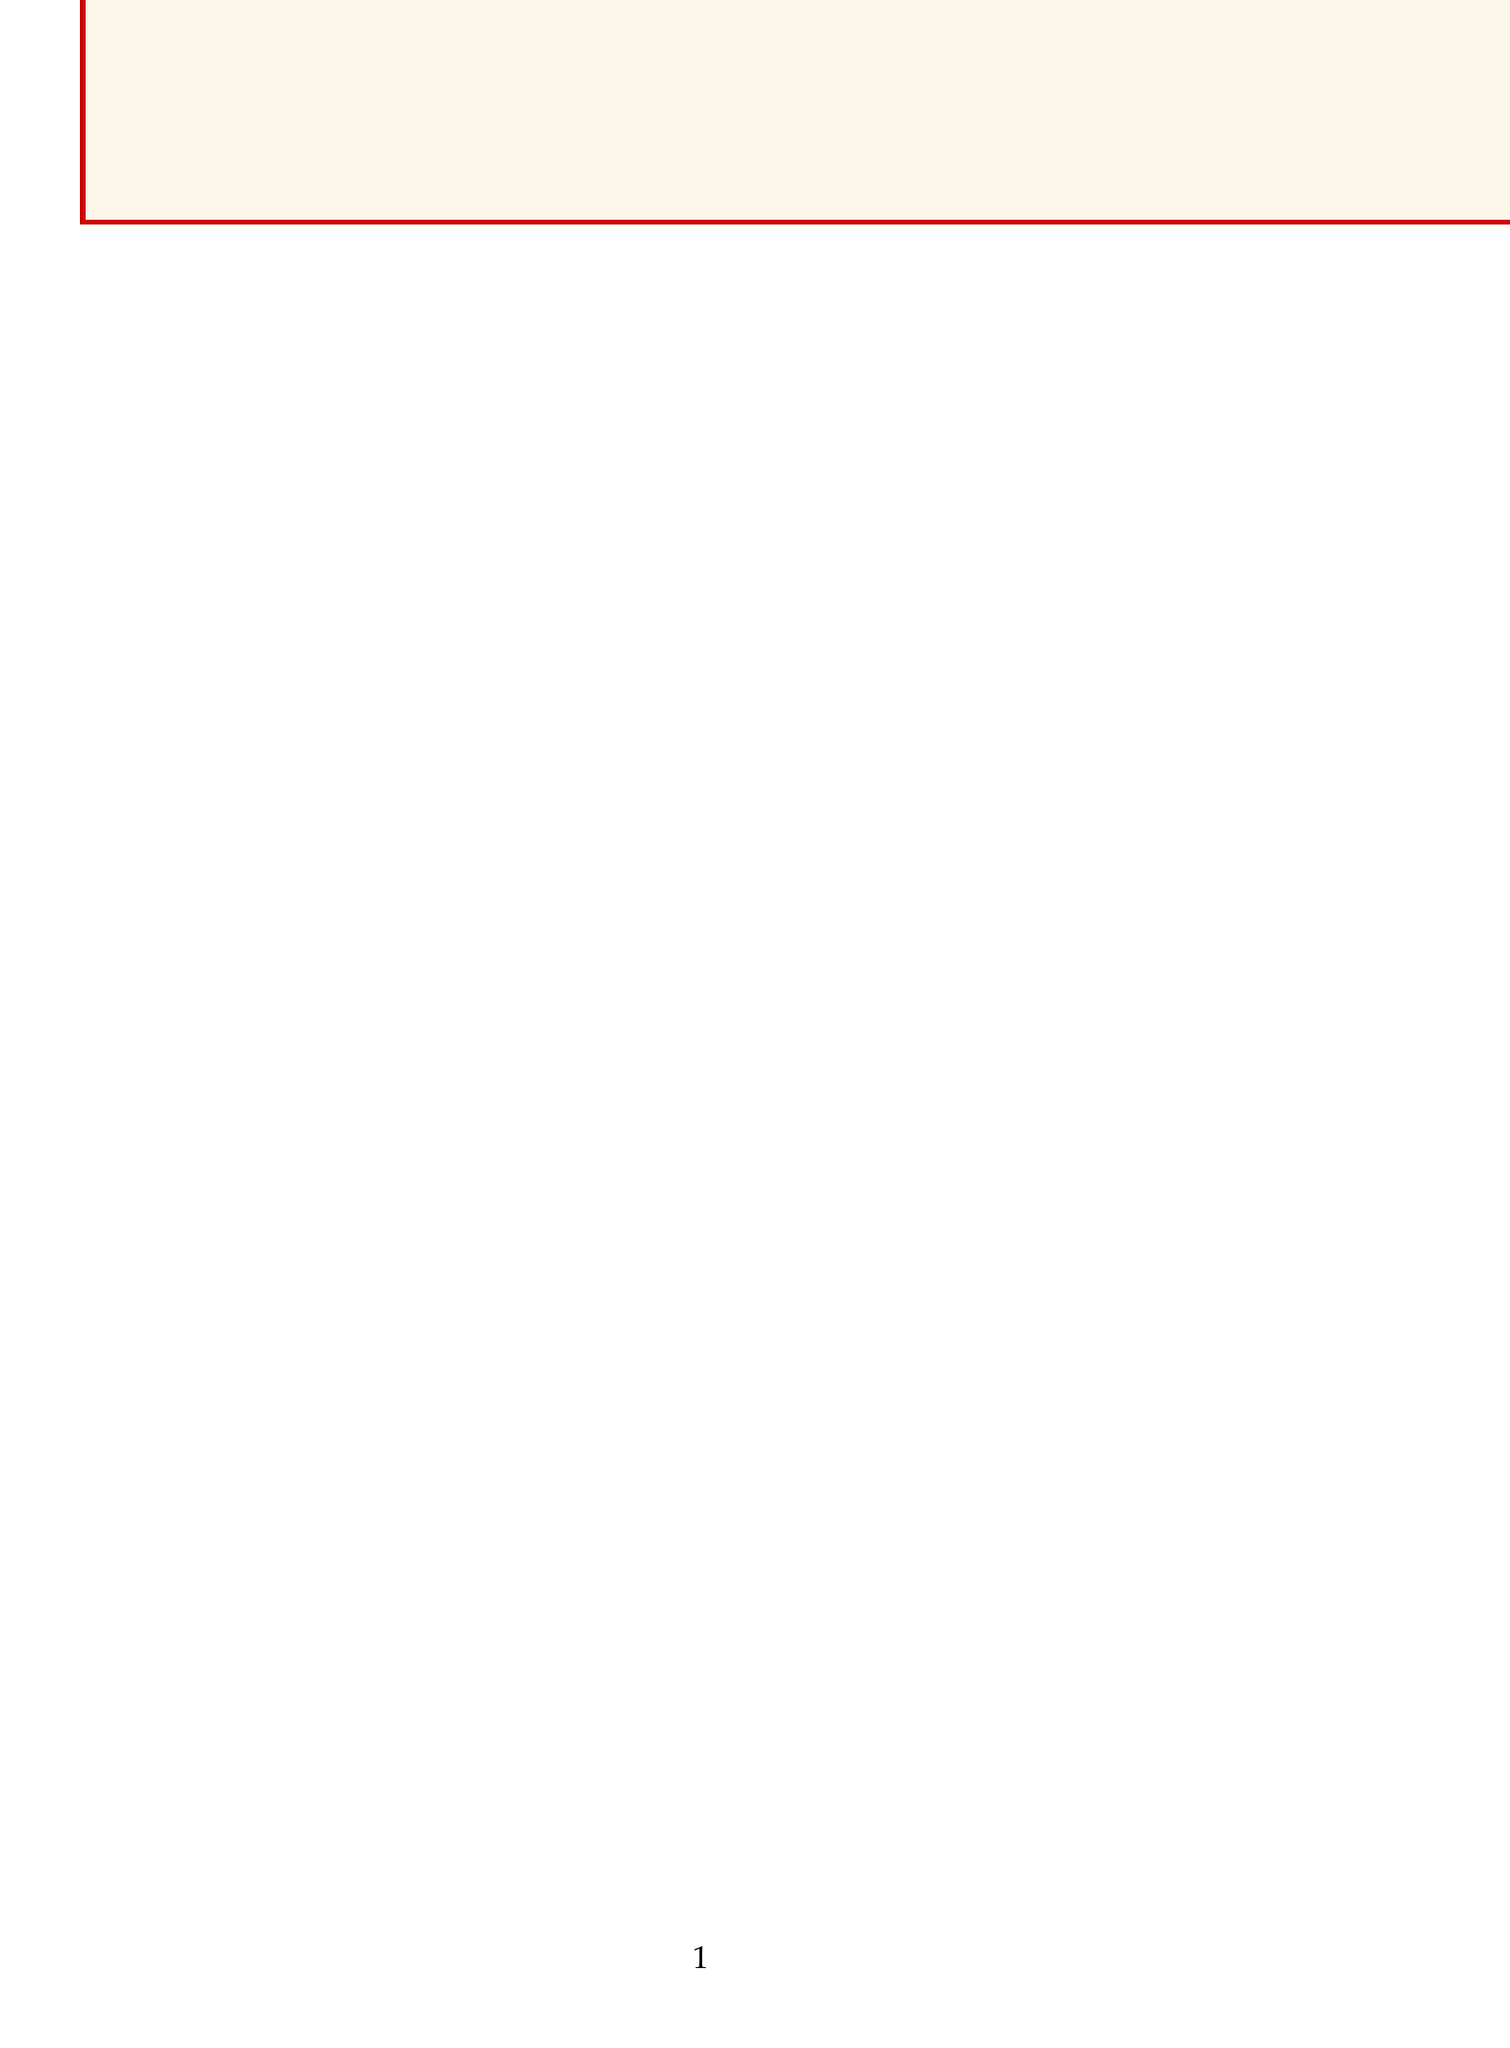What is the recipient's title? The document states the recipient's title as "Chief Historian, Boston Historical Society."
Answer: Chief Historian, Boston Historical Society What is the date of the forum? The document provides the specific date of the forum as September 15, 2023.
Answer: September 15, 2023 What key topic will be discussed at the forum? The letter mentions the critical topic as "Integrating Historical Landmarks into Urban Development Plans."
Answer: Integrating Historical Landmarks into Urban Development Plans What is one specific landmark mentioned in the letter? The letter lists several landmarks; one of them is "Freedom Trail."
Answer: Freedom Trail What are two of the development challenges mentioned? The document lists various challenges, including "Zoning regulations in historic districts" and "Funding for preservation projects."
Answer: Zoning regulations in historic districts, Funding for preservation projects Why is Dr. Thornton being invited? The letter states that Dr. Thornton's expertise would be invaluable to the discussions on integrating historical landmarks into urban development plans.
Answer: Expertise on integrating historical landmarks What is one expected outcome of the forum? The letter states that one expected outcome is "Draft guidelines for integrating landmarks into development plans."
Answer: Draft guidelines for integrating landmarks into development plans What type of projects does the letter refer to regarding community benefit? The document references "recent projects," such as the restoration of the Old State House.
Answer: Restoration of the Old State House What is the closing salutation used in the letter? The letter uses "Sincerely," as the closing salutation before the signature.
Answer: Sincerely 